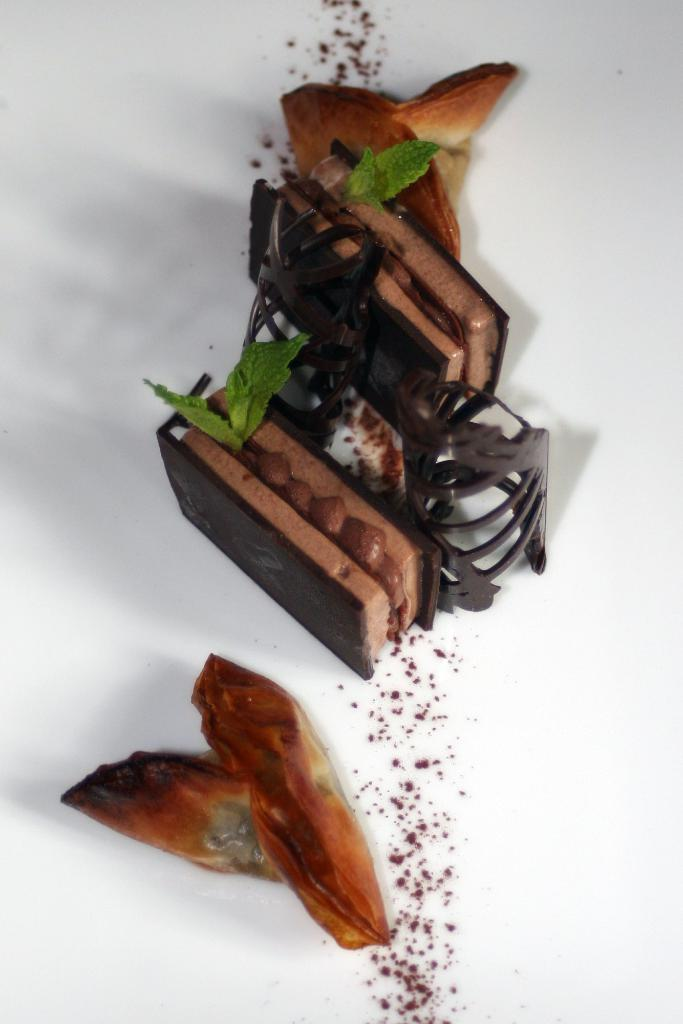What type of food items can be seen in the image? There are two biscuits in the image. What is the substance between the biscuits? There is chocolate cream in the image. What type of natural elements are present in the image? There are leaves in the image. What color is the background of the image? The background of the image is white. What type of lead can be seen in the image? There is no lead present in the image. Is there a drawer visible in the image? There is no drawer visible in the image. 